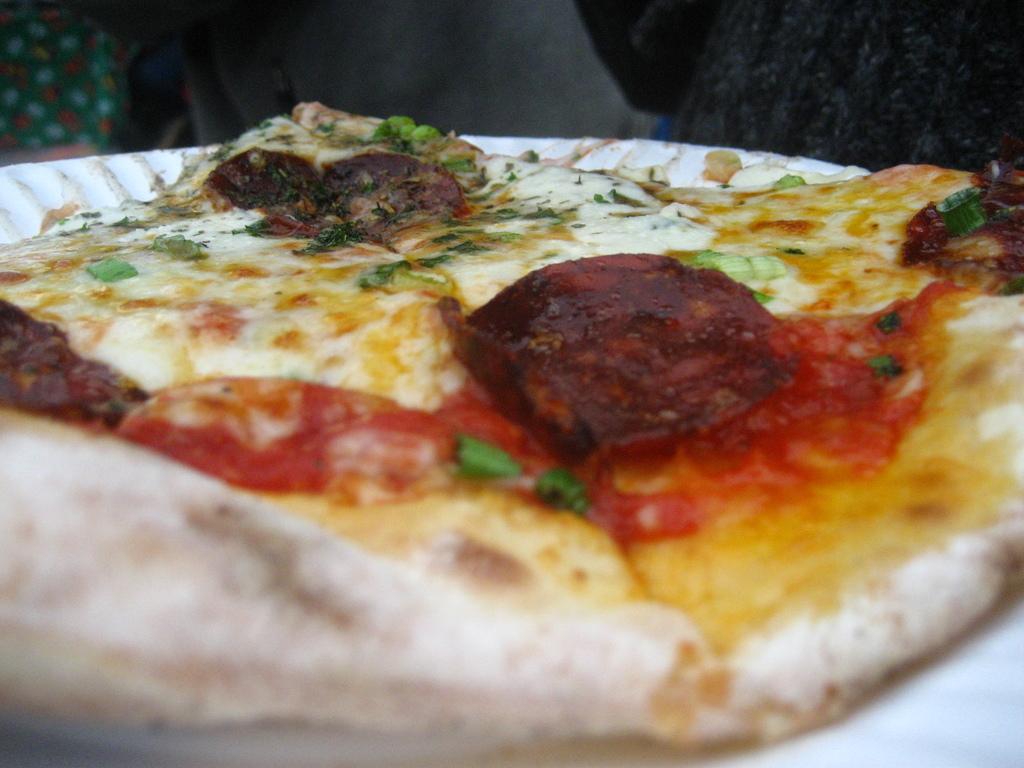How would you summarize this image in a sentence or two? In this picture, we see an edible. In the right top, it is black in color. In the left top, we see an object in green color. In the background, it is grey in color. 